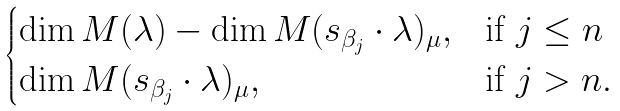Convert formula to latex. <formula><loc_0><loc_0><loc_500><loc_500>\begin{cases} \dim M ( \lambda ) - \dim M ( s _ { \beta _ { j } } \cdot \lambda ) _ { \mu } , & \text {if } j \leq n \\ \dim M ( s _ { \beta _ { j } } \cdot \lambda ) _ { \mu } , & \text {if } j > n . \end{cases}</formula> 